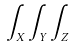Convert formula to latex. <formula><loc_0><loc_0><loc_500><loc_500>\int _ { X } \int _ { Y } \int _ { Z }</formula> 